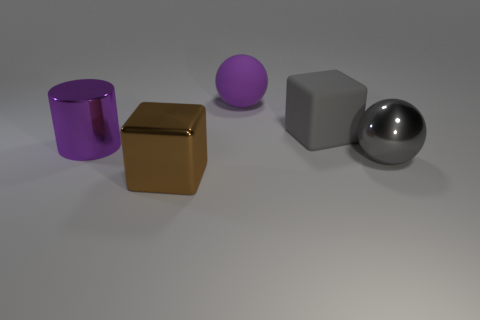There is a big metal object that is in front of the metal ball; what shape is it?
Ensure brevity in your answer.  Cube. What color is the rubber object that is the same size as the rubber ball?
Give a very brief answer. Gray. Do the gray object in front of the big shiny cylinder and the brown cube have the same material?
Your response must be concise. Yes. There is a thing that is in front of the purple matte sphere and behind the large purple metal cylinder; what size is it?
Your response must be concise. Large. What is the size of the gray object in front of the metallic cylinder?
Give a very brief answer. Large. There is a large rubber thing that is the same color as the metal sphere; what shape is it?
Make the answer very short. Cube. There is a thing in front of the sphere on the right side of the big purple thing on the right side of the big brown metal cube; what shape is it?
Give a very brief answer. Cube. How many other things are there of the same shape as the large gray matte thing?
Provide a succinct answer. 1. What number of metal objects are big spheres or blocks?
Your response must be concise. 2. What material is the purple object left of the large brown cube that is in front of the big purple cylinder made of?
Your response must be concise. Metal. 